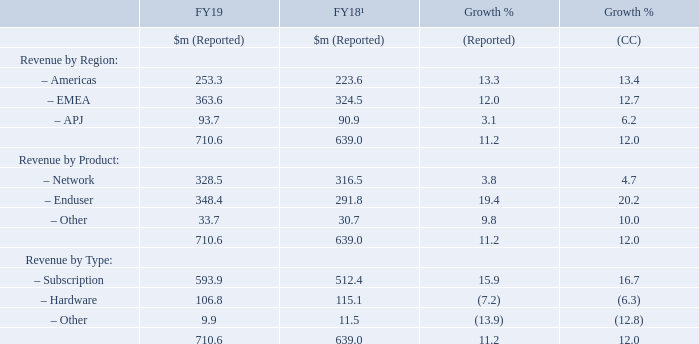Revenue and deferred revenue
The Group adopted IFRS 15 Revenue from Contracts with Customers in the current year and has therefore restated the results for the prior-year on a consistent basis, see note 2 of the Financial Statements for further details.
The Group’s revenue increased by $71.6 million, or 11.2 per cent, to $710.6 million in the year-ended 31 March 2019. Subscription revenue was notably strong in the period, with reported growth of 15.9 per cent, or 16.7 per cent on a constant currency basis, because of strong prior-period billings and incremental growth of the MSP channel in the current period.
1 Restated for the adoption of IFRS 15 as explained in note 2 of the Financial Statements
Revenue in the period of $710.6 million comprised $394.1 million from the recognition of prior-period deferred revenues and $316.5 million from in-period billings. The majority of the Group’s billings, which are recognised over the life of the contract, relate to subscription products (FY19: 84.8 per cent; FY18: 83.8 per cent), with the benefit from increased billings being spread over a number of years on the subsequent recognition of deferred revenue. The deferred revenue balance at the end of the period of $742.1 million increased $13.5 million year-on-year, an increase of 1.9 per cent. This was mainly due to a net deferral of billings amounting to $49.7 million partially offset by a net currency revaluation of $36.2 million, a consequence of the weakening of the euro and sterling against the US dollar during the year. Deferred revenue due within one year at the balance sheet date of $428.6M increased by 5.1 per cent at actual rates or by 10.7 per cent in constant currency.
Revenue in the Americas increased by $29.7 million or 13.3 per cent to $253.3 million in the year-ended 31 March 2019, supported by the recognition of prior-period Enduser billings from the Sophos Central platform and the growth of the MSP channel in the current period.
EMEA revenue increased by $39.1 million or 12.0 per cent to $363.6 million in the year-ended 31 March 2019, with growth in Enduser in particular, but also aided by Network sales.
APJ revenue increased by $2.8 million, or 3.1 per cent to $93.7 million in the year-ended 31 March 2019, with good growth in Enduser products partially offset by a decline in Network sales following the legacy product transition.
What was the reported percentage increase in EMEA revenue in 2019 from 2018? 12.0 per cent. What was the reported percentage increase in APJ revenue in 2019 from 2018? 3.1 per cent. What are the different regions under Revenue by Region in the table? Americas, emea, apj. In which year was the revenue in the Americas larger? 253.3>223.6
Answer: 2019. What was the change in Network from 2019 to 2018 under Revenue by Product?
Answer scale should be: million. 328.5-316.5
Answer: 12. What was the average revenue earned across 2018 and 2019?
Answer scale should be: million. (710.6+639.0)/2
Answer: 674.8. 